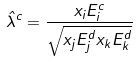<formula> <loc_0><loc_0><loc_500><loc_500>\hat { \lambda } ^ { c } = \frac { x _ { i } E _ { i } ^ { c } } { \sqrt { x _ { j } E _ { j } ^ { d } x _ { k } E _ { k } ^ { d } } }</formula> 